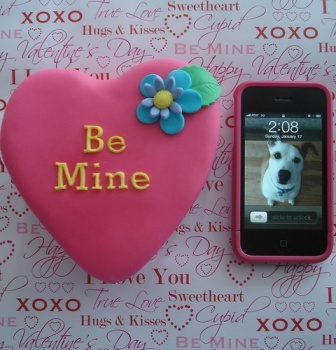Can you tell more about the significance of the phrases and colors used in the background? Certainly! The background is adorned with words and phrases like 'Sweetheart', 'XOXO', and 'Hugs & Kisses', commonly associated with expressions of love and affection, particularly during Valentine's Day. The choice of red and pink hues enhances the romantic atmosphere, as these colors are traditionally linked to love and passion. This thoughtful arrangement adds depth to the image, making it not just visually appealing but also emotionally resonant. 